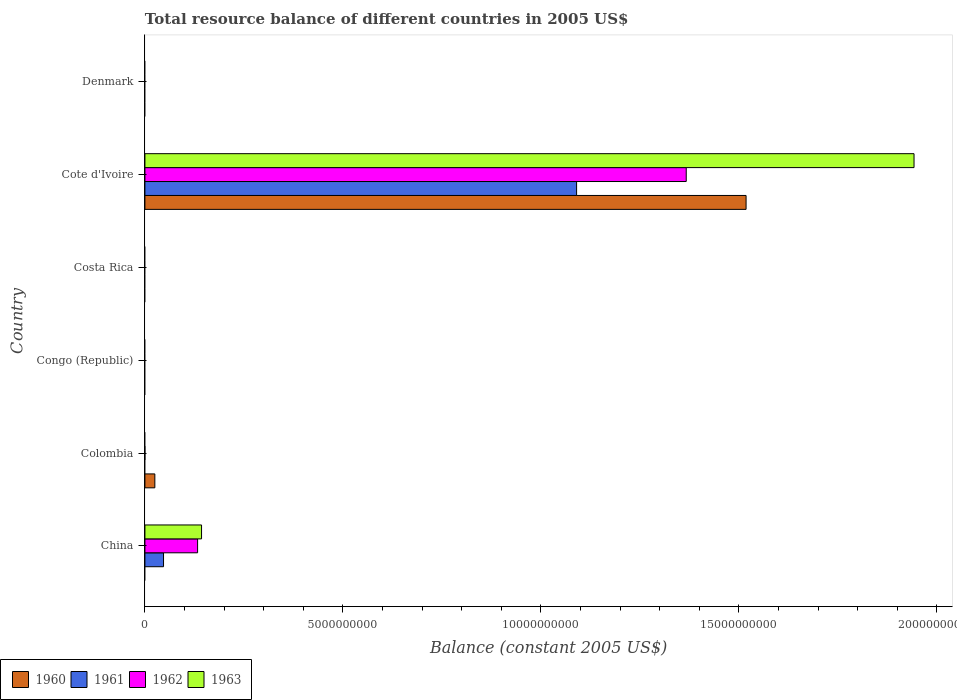How many different coloured bars are there?
Give a very brief answer. 4. Are the number of bars per tick equal to the number of legend labels?
Offer a very short reply. No. How many bars are there on the 6th tick from the top?
Provide a succinct answer. 3. What is the total resource balance in 1961 in Denmark?
Make the answer very short. 0. Across all countries, what is the maximum total resource balance in 1962?
Provide a succinct answer. 1.37e+1. Across all countries, what is the minimum total resource balance in 1962?
Keep it short and to the point. 0. In which country was the total resource balance in 1962 maximum?
Provide a short and direct response. Cote d'Ivoire. What is the total total resource balance in 1962 in the graph?
Provide a succinct answer. 1.50e+1. What is the difference between the total resource balance in 1960 in Colombia and that in Cote d'Ivoire?
Provide a succinct answer. -1.49e+1. What is the difference between the total resource balance in 1960 in Colombia and the total resource balance in 1961 in Costa Rica?
Offer a very short reply. 2.51e+08. What is the average total resource balance in 1961 per country?
Your response must be concise. 1.90e+09. What is the difference between the total resource balance in 1961 and total resource balance in 1962 in Cote d'Ivoire?
Make the answer very short. -2.77e+09. In how many countries, is the total resource balance in 1960 greater than 6000000000 US$?
Keep it short and to the point. 1. What is the difference between the highest and the lowest total resource balance in 1963?
Ensure brevity in your answer.  1.94e+1. Is the sum of the total resource balance in 1962 in China and Cote d'Ivoire greater than the maximum total resource balance in 1963 across all countries?
Offer a very short reply. No. Is it the case that in every country, the sum of the total resource balance in 1960 and total resource balance in 1962 is greater than the sum of total resource balance in 1961 and total resource balance in 1963?
Offer a terse response. No. Is it the case that in every country, the sum of the total resource balance in 1963 and total resource balance in 1960 is greater than the total resource balance in 1961?
Give a very brief answer. No. How many bars are there?
Make the answer very short. 8. What is the difference between two consecutive major ticks on the X-axis?
Ensure brevity in your answer.  5.00e+09. Are the values on the major ticks of X-axis written in scientific E-notation?
Provide a short and direct response. No. Does the graph contain any zero values?
Offer a terse response. Yes. Does the graph contain grids?
Give a very brief answer. No. How many legend labels are there?
Offer a terse response. 4. How are the legend labels stacked?
Give a very brief answer. Horizontal. What is the title of the graph?
Offer a very short reply. Total resource balance of different countries in 2005 US$. Does "2008" appear as one of the legend labels in the graph?
Offer a terse response. No. What is the label or title of the X-axis?
Keep it short and to the point. Balance (constant 2005 US$). What is the label or title of the Y-axis?
Ensure brevity in your answer.  Country. What is the Balance (constant 2005 US$) in 1960 in China?
Give a very brief answer. 0. What is the Balance (constant 2005 US$) in 1961 in China?
Ensure brevity in your answer.  4.70e+08. What is the Balance (constant 2005 US$) in 1962 in China?
Ensure brevity in your answer.  1.33e+09. What is the Balance (constant 2005 US$) of 1963 in China?
Offer a terse response. 1.43e+09. What is the Balance (constant 2005 US$) in 1960 in Colombia?
Offer a very short reply. 2.51e+08. What is the Balance (constant 2005 US$) in 1962 in Congo (Republic)?
Your response must be concise. 0. What is the Balance (constant 2005 US$) of 1963 in Congo (Republic)?
Offer a very short reply. 0. What is the Balance (constant 2005 US$) in 1960 in Costa Rica?
Your response must be concise. 0. What is the Balance (constant 2005 US$) of 1961 in Costa Rica?
Keep it short and to the point. 0. What is the Balance (constant 2005 US$) of 1963 in Costa Rica?
Ensure brevity in your answer.  0. What is the Balance (constant 2005 US$) of 1960 in Cote d'Ivoire?
Your response must be concise. 1.52e+1. What is the Balance (constant 2005 US$) of 1961 in Cote d'Ivoire?
Provide a succinct answer. 1.09e+1. What is the Balance (constant 2005 US$) in 1962 in Cote d'Ivoire?
Your response must be concise. 1.37e+1. What is the Balance (constant 2005 US$) in 1963 in Cote d'Ivoire?
Make the answer very short. 1.94e+1. What is the Balance (constant 2005 US$) in 1960 in Denmark?
Offer a very short reply. 0. What is the Balance (constant 2005 US$) of 1962 in Denmark?
Keep it short and to the point. 0. Across all countries, what is the maximum Balance (constant 2005 US$) of 1960?
Give a very brief answer. 1.52e+1. Across all countries, what is the maximum Balance (constant 2005 US$) of 1961?
Provide a succinct answer. 1.09e+1. Across all countries, what is the maximum Balance (constant 2005 US$) in 1962?
Offer a terse response. 1.37e+1. Across all countries, what is the maximum Balance (constant 2005 US$) of 1963?
Keep it short and to the point. 1.94e+1. What is the total Balance (constant 2005 US$) in 1960 in the graph?
Provide a short and direct response. 1.54e+1. What is the total Balance (constant 2005 US$) of 1961 in the graph?
Make the answer very short. 1.14e+1. What is the total Balance (constant 2005 US$) in 1962 in the graph?
Ensure brevity in your answer.  1.50e+1. What is the total Balance (constant 2005 US$) in 1963 in the graph?
Offer a very short reply. 2.09e+1. What is the difference between the Balance (constant 2005 US$) of 1961 in China and that in Cote d'Ivoire?
Offer a very short reply. -1.04e+1. What is the difference between the Balance (constant 2005 US$) in 1962 in China and that in Cote d'Ivoire?
Offer a terse response. -1.23e+1. What is the difference between the Balance (constant 2005 US$) in 1963 in China and that in Cote d'Ivoire?
Your answer should be very brief. -1.80e+1. What is the difference between the Balance (constant 2005 US$) of 1960 in Colombia and that in Cote d'Ivoire?
Your answer should be very brief. -1.49e+1. What is the difference between the Balance (constant 2005 US$) in 1961 in China and the Balance (constant 2005 US$) in 1962 in Cote d'Ivoire?
Make the answer very short. -1.32e+1. What is the difference between the Balance (constant 2005 US$) in 1961 in China and the Balance (constant 2005 US$) in 1963 in Cote d'Ivoire?
Make the answer very short. -1.90e+1. What is the difference between the Balance (constant 2005 US$) in 1962 in China and the Balance (constant 2005 US$) in 1963 in Cote d'Ivoire?
Give a very brief answer. -1.81e+1. What is the difference between the Balance (constant 2005 US$) in 1960 in Colombia and the Balance (constant 2005 US$) in 1961 in Cote d'Ivoire?
Offer a terse response. -1.07e+1. What is the difference between the Balance (constant 2005 US$) of 1960 in Colombia and the Balance (constant 2005 US$) of 1962 in Cote d'Ivoire?
Your response must be concise. -1.34e+1. What is the difference between the Balance (constant 2005 US$) of 1960 in Colombia and the Balance (constant 2005 US$) of 1963 in Cote d'Ivoire?
Provide a short and direct response. -1.92e+1. What is the average Balance (constant 2005 US$) of 1960 per country?
Offer a terse response. 2.57e+09. What is the average Balance (constant 2005 US$) of 1961 per country?
Provide a succinct answer. 1.90e+09. What is the average Balance (constant 2005 US$) in 1962 per country?
Offer a terse response. 2.50e+09. What is the average Balance (constant 2005 US$) in 1963 per country?
Your answer should be very brief. 3.48e+09. What is the difference between the Balance (constant 2005 US$) of 1961 and Balance (constant 2005 US$) of 1962 in China?
Your response must be concise. -8.60e+08. What is the difference between the Balance (constant 2005 US$) of 1961 and Balance (constant 2005 US$) of 1963 in China?
Your answer should be very brief. -9.60e+08. What is the difference between the Balance (constant 2005 US$) of 1962 and Balance (constant 2005 US$) of 1963 in China?
Provide a succinct answer. -1.00e+08. What is the difference between the Balance (constant 2005 US$) in 1960 and Balance (constant 2005 US$) in 1961 in Cote d'Ivoire?
Provide a succinct answer. 4.28e+09. What is the difference between the Balance (constant 2005 US$) in 1960 and Balance (constant 2005 US$) in 1962 in Cote d'Ivoire?
Offer a very short reply. 1.51e+09. What is the difference between the Balance (constant 2005 US$) of 1960 and Balance (constant 2005 US$) of 1963 in Cote d'Ivoire?
Your answer should be compact. -4.24e+09. What is the difference between the Balance (constant 2005 US$) in 1961 and Balance (constant 2005 US$) in 1962 in Cote d'Ivoire?
Your response must be concise. -2.77e+09. What is the difference between the Balance (constant 2005 US$) of 1961 and Balance (constant 2005 US$) of 1963 in Cote d'Ivoire?
Provide a succinct answer. -8.52e+09. What is the difference between the Balance (constant 2005 US$) of 1962 and Balance (constant 2005 US$) of 1963 in Cote d'Ivoire?
Offer a terse response. -5.75e+09. What is the ratio of the Balance (constant 2005 US$) in 1961 in China to that in Cote d'Ivoire?
Offer a terse response. 0.04. What is the ratio of the Balance (constant 2005 US$) in 1962 in China to that in Cote d'Ivoire?
Your answer should be compact. 0.1. What is the ratio of the Balance (constant 2005 US$) of 1963 in China to that in Cote d'Ivoire?
Your response must be concise. 0.07. What is the ratio of the Balance (constant 2005 US$) of 1960 in Colombia to that in Cote d'Ivoire?
Offer a terse response. 0.02. What is the difference between the highest and the lowest Balance (constant 2005 US$) of 1960?
Give a very brief answer. 1.52e+1. What is the difference between the highest and the lowest Balance (constant 2005 US$) in 1961?
Your response must be concise. 1.09e+1. What is the difference between the highest and the lowest Balance (constant 2005 US$) of 1962?
Your answer should be compact. 1.37e+1. What is the difference between the highest and the lowest Balance (constant 2005 US$) in 1963?
Offer a very short reply. 1.94e+1. 